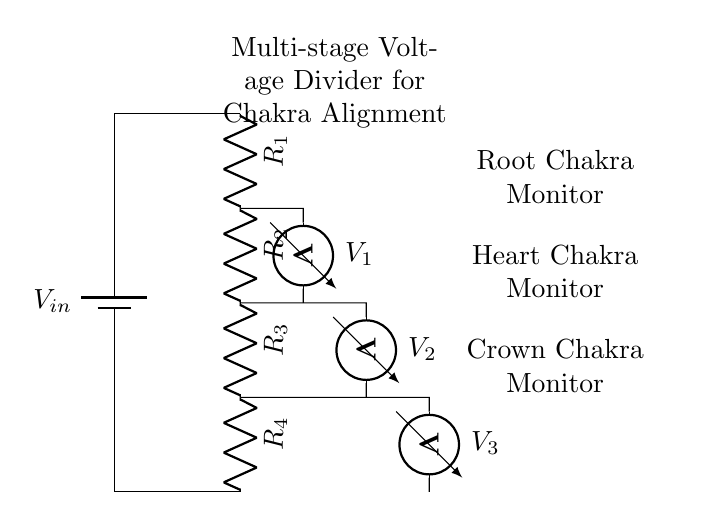What is the input voltage of this circuit? The input voltage is represented by \( V_{in} \), which is the voltage supplied by the battery at the top of the circuit.
Answer: \( V_{in} \) How many resistors are in the circuit? There are four resistors labeled \( R_1 \), \( R_2 \), \( R_3 \), and \( R_4 \) in the circuit as shown in the diagram.
Answer: 4 What does the voltmeter \( V_1 \) measure? The voltmeter \( V_1 \) measures the voltage drop across the first resistor \( R_1 \) in the voltage divider, providing the voltage between the point where \( R_1 \) is connected and the ground.
Answer: \( V_1 \) What is the purpose of the multi-stage voltage divider in this circuit? The purpose is to monitor energy levels at specific chakras, indicated by the labels on the voltmeters for the Root, Heart, and Crown Chakras.
Answer: Chakra monitoring What is the voltage at the output of the last resistor? The voltage at the output of the last resistor \( R_4 \) is typically ground or zero as it's connected to the bottom of the voltage divider.
Answer: 0 volts How does the voltage change across the resistors? The voltage drop across each resistor depends on its resistance value and the total input voltage; using the voltage divider rule, the voltage across each resistor can be calculated based on their resistance values.
Answer: Divides by resistances 